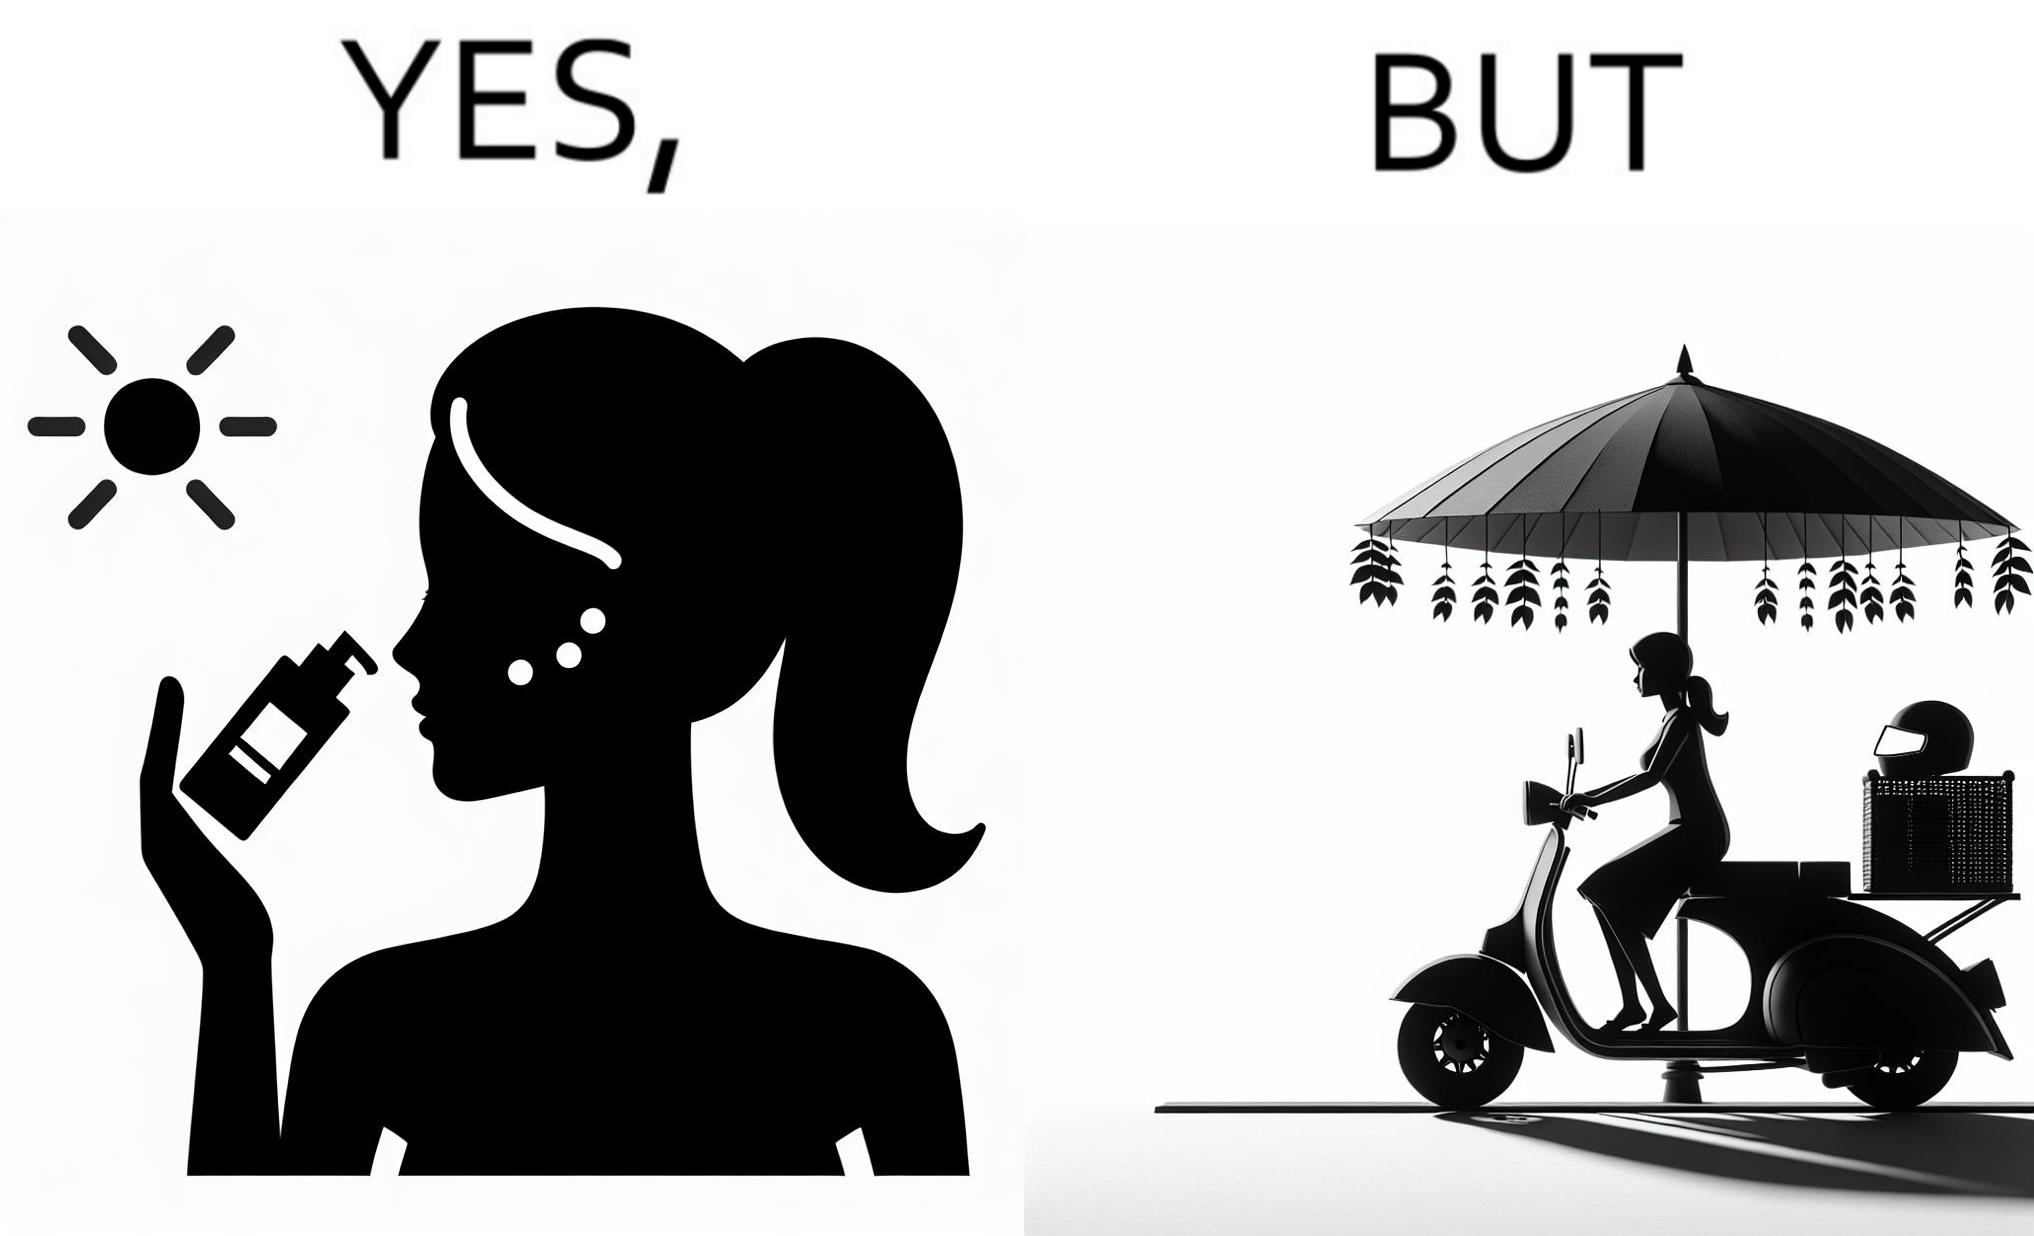Is this image satirical or non-satirical? Yes, this image is satirical. 